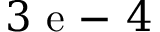Convert formula to latex. <formula><loc_0><loc_0><loc_500><loc_500>3 e - 4</formula> 